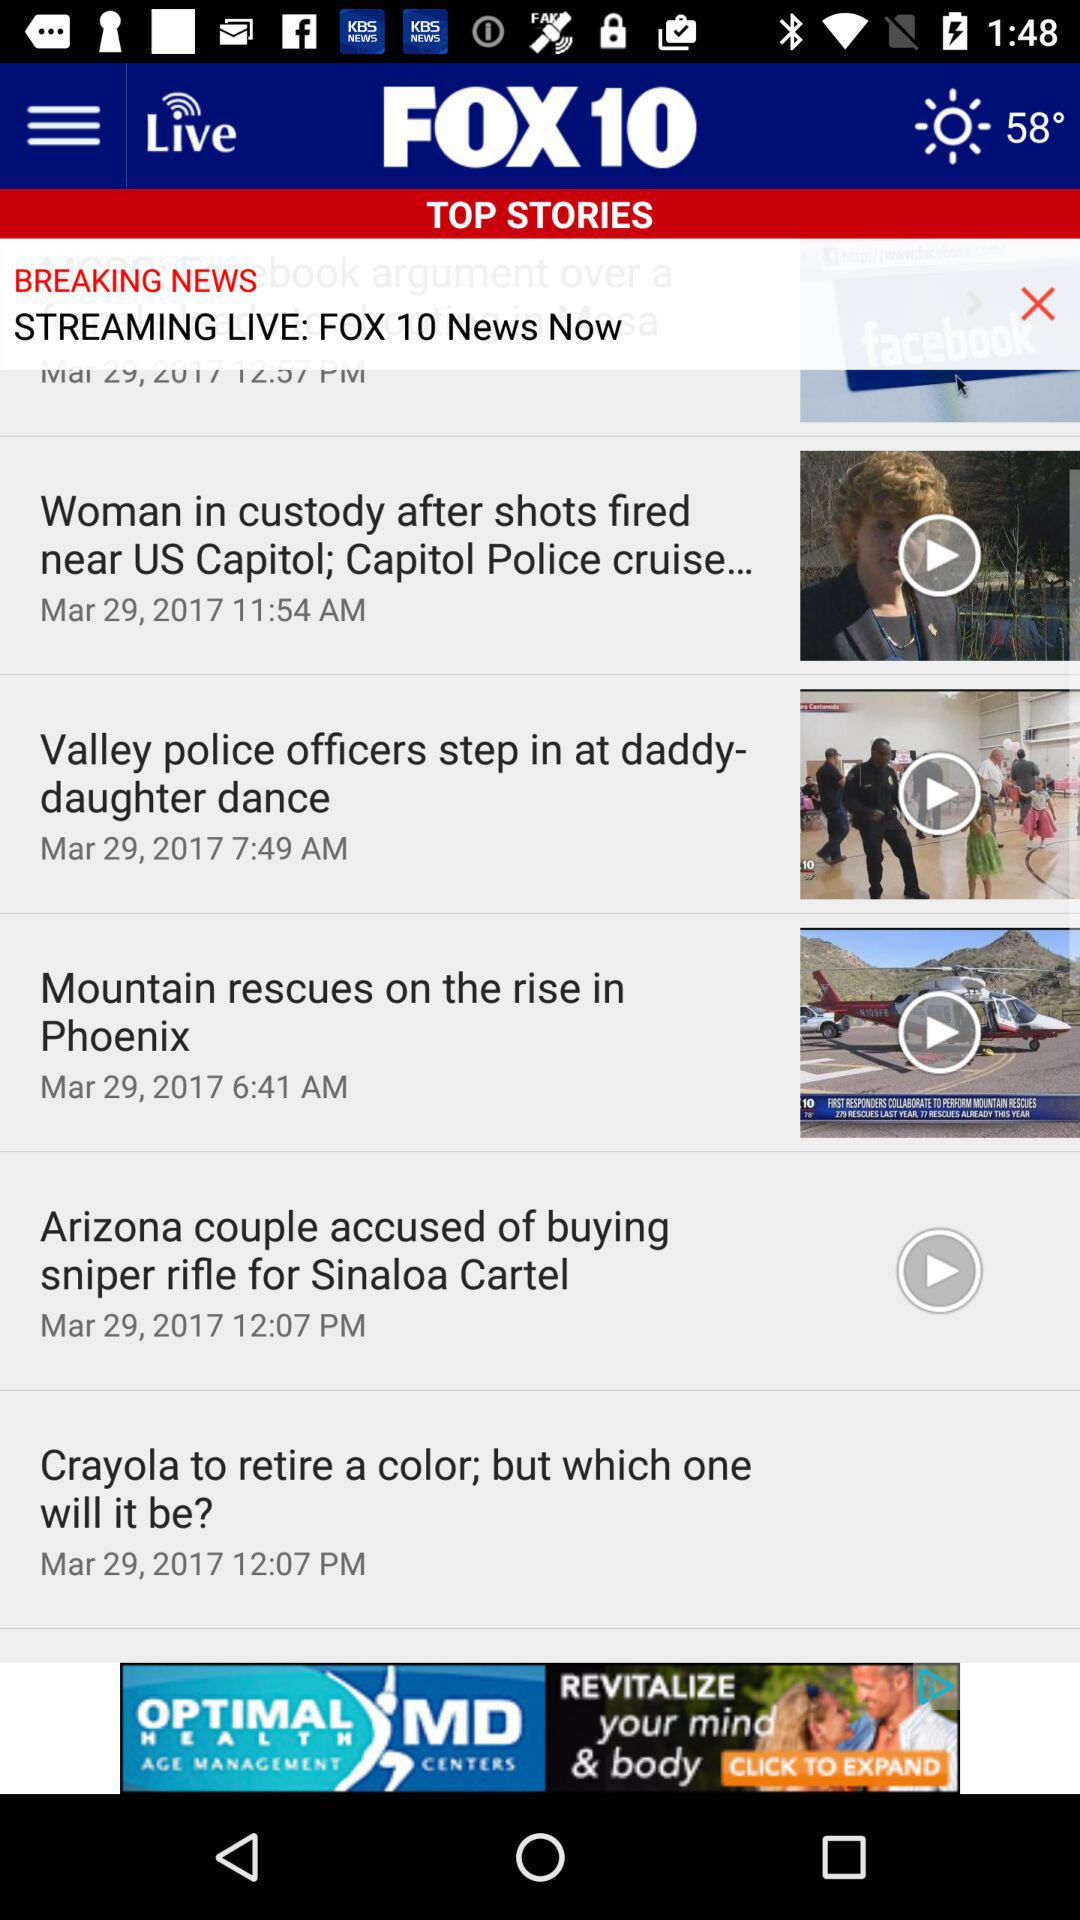When was the "Valley police officers" news posted? The news was posted on March 29, 2017 at 7:49 AM. 